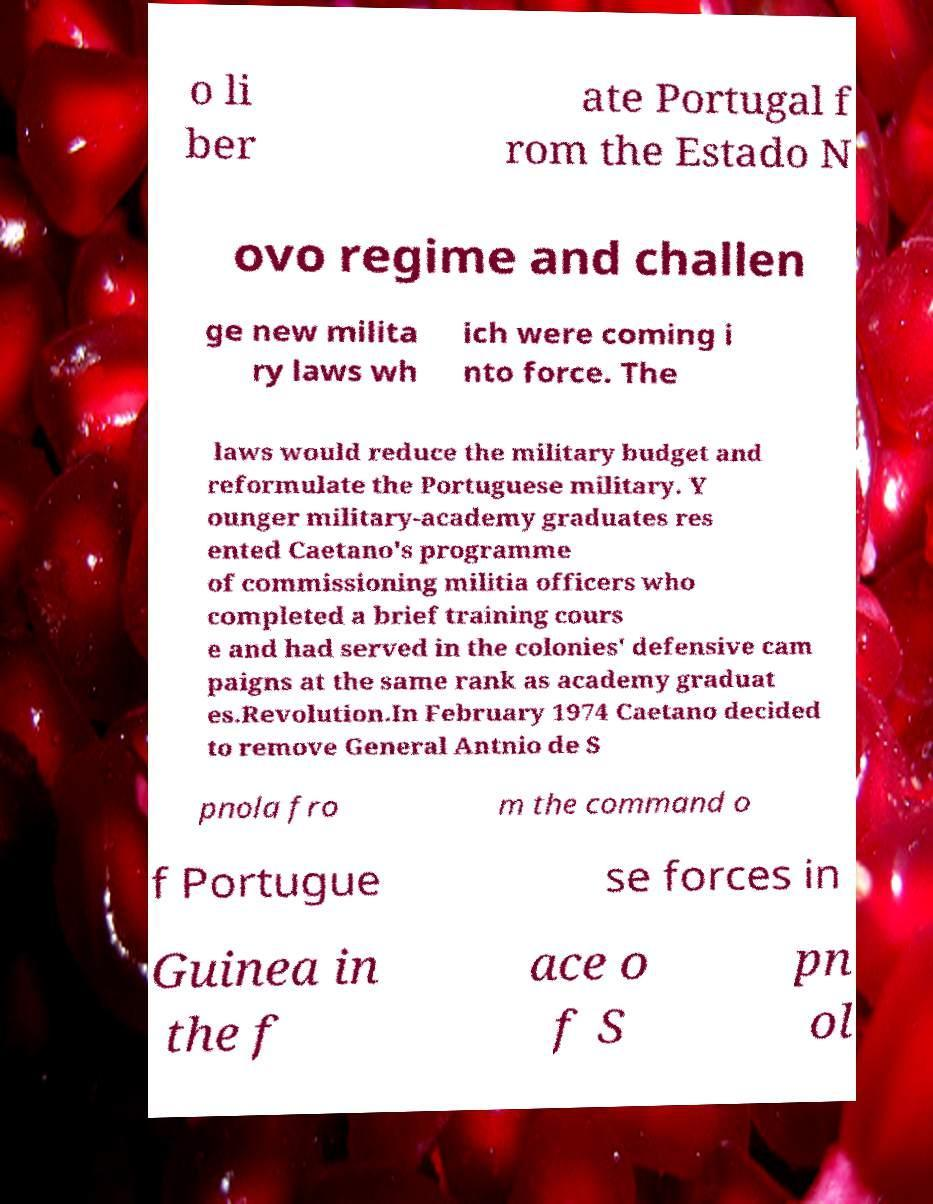Can you accurately transcribe the text from the provided image for me? o li ber ate Portugal f rom the Estado N ovo regime and challen ge new milita ry laws wh ich were coming i nto force. The laws would reduce the military budget and reformulate the Portuguese military. Y ounger military-academy graduates res ented Caetano's programme of commissioning militia officers who completed a brief training cours e and had served in the colonies' defensive cam paigns at the same rank as academy graduat es.Revolution.In February 1974 Caetano decided to remove General Antnio de S pnola fro m the command o f Portugue se forces in Guinea in the f ace o f S pn ol 